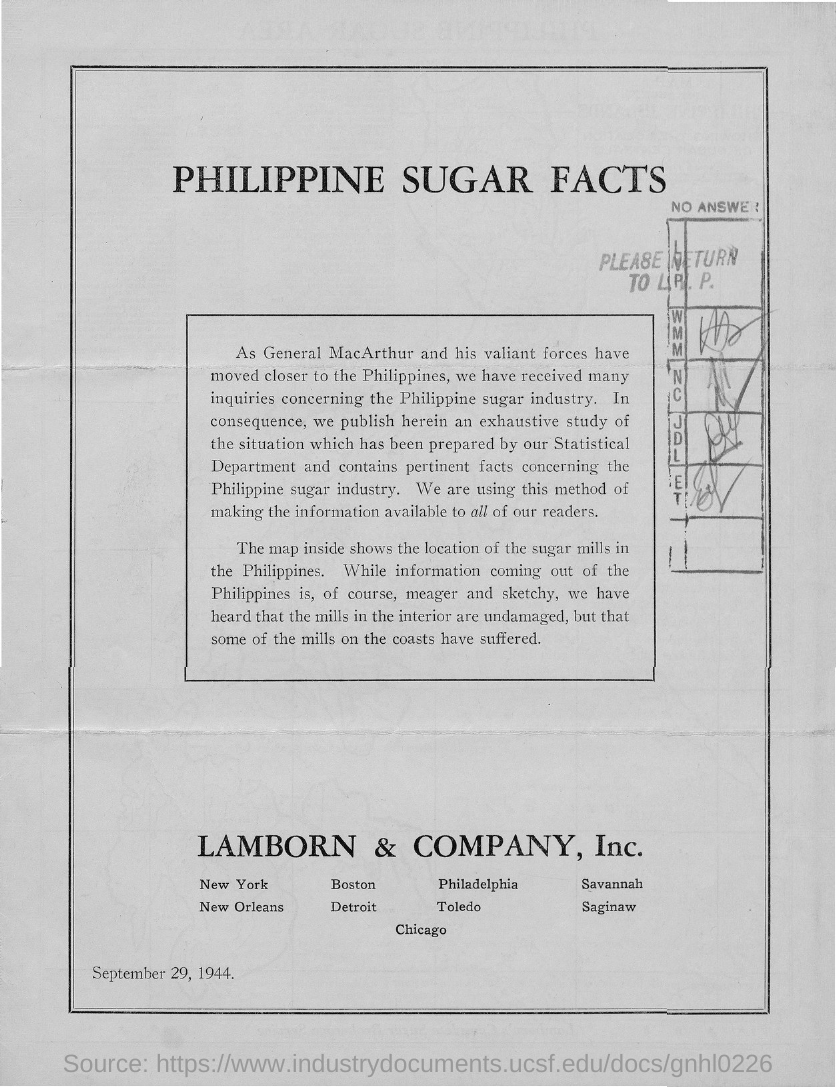Indicate a few pertinent items in this graphic. LAMBORN & COMPANY, Inc. is mentioned in this document. The date mentioned in this document is September 29, 1944. The title of this document is "Philippine Sugar Facts". 